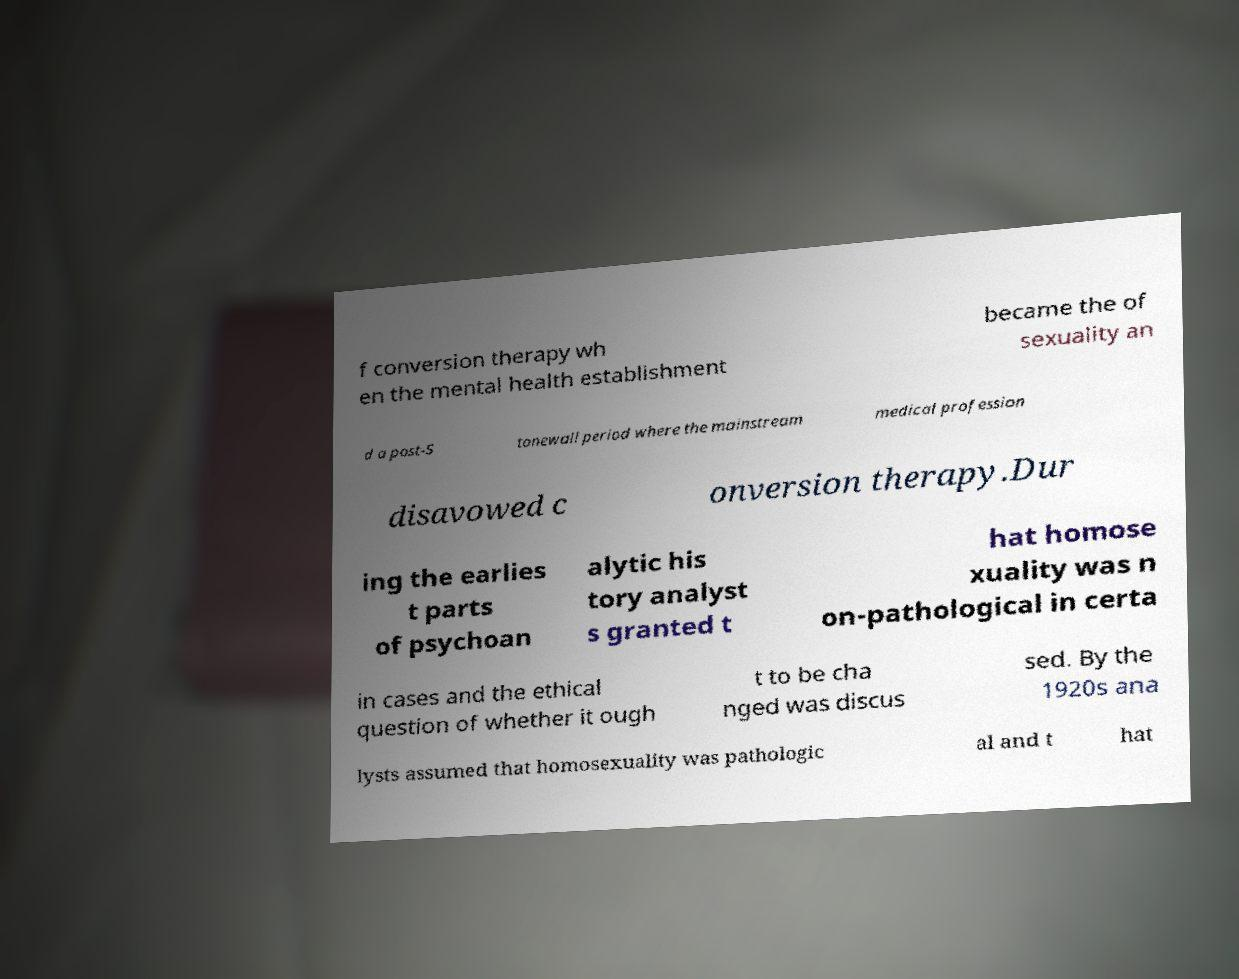What messages or text are displayed in this image? I need them in a readable, typed format. f conversion therapy wh en the mental health establishment became the of sexuality an d a post-S tonewall period where the mainstream medical profession disavowed c onversion therapy.Dur ing the earlies t parts of psychoan alytic his tory analyst s granted t hat homose xuality was n on-pathological in certa in cases and the ethical question of whether it ough t to be cha nged was discus sed. By the 1920s ana lysts assumed that homosexuality was pathologic al and t hat 